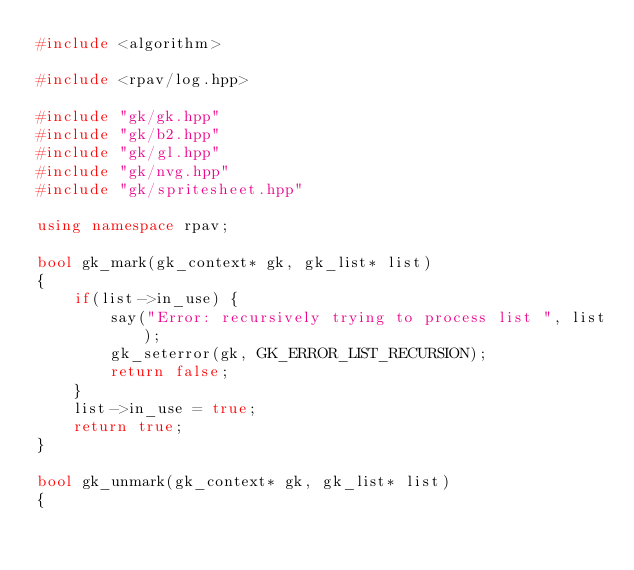Convert code to text. <code><loc_0><loc_0><loc_500><loc_500><_C++_>#include <algorithm>

#include <rpav/log.hpp>

#include "gk/gk.hpp"
#include "gk/b2.hpp"
#include "gk/gl.hpp"
#include "gk/nvg.hpp"
#include "gk/spritesheet.hpp"

using namespace rpav;

bool gk_mark(gk_context* gk, gk_list* list)
{
    if(list->in_use) {
        say("Error: recursively trying to process list ", list);
        gk_seterror(gk, GK_ERROR_LIST_RECURSION);
        return false;
    }
    list->in_use = true;
    return true;
}

bool gk_unmark(gk_context* gk, gk_list* list)
{</code> 